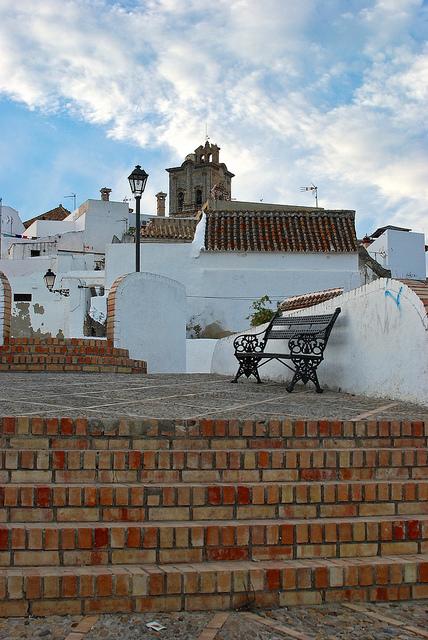Is anyone sitting on the bench?
Concise answer only. No. How many red squares are there?
Keep it brief. 100. How many steps lead up to the statue?
Answer briefly. 5. Is this a beach?
Be succinct. No. Is this at a zoo?
Be succinct. No. Are the streets brick?
Concise answer only. Yes. How many stair steps do you count?
Concise answer only. 8. 